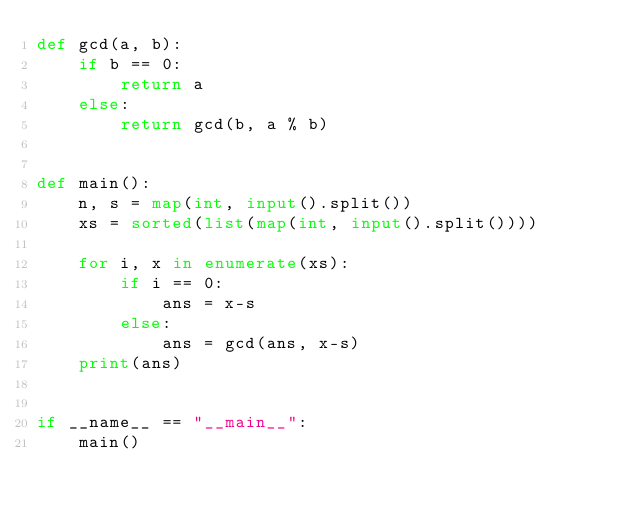<code> <loc_0><loc_0><loc_500><loc_500><_Python_>def gcd(a, b):
    if b == 0:
        return a
    else:
        return gcd(b, a % b)


def main():
    n, s = map(int, input().split())
    xs = sorted(list(map(int, input().split())))

    for i, x in enumerate(xs):
        if i == 0:
            ans = x-s
        else:
            ans = gcd(ans, x-s)
    print(ans)


if __name__ == "__main__":
    main()
</code> 